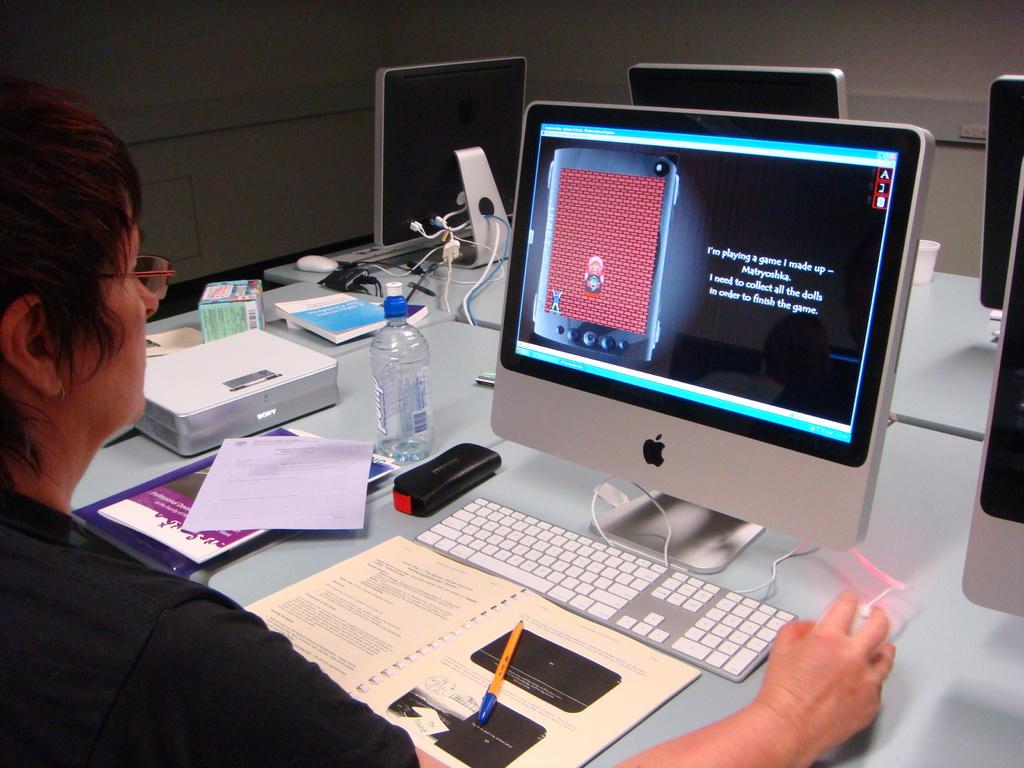What does the first sentence say on this computer screen?
Your answer should be very brief. I'm playing a game i made up. What do they need to collect?
Make the answer very short. Dolls. 